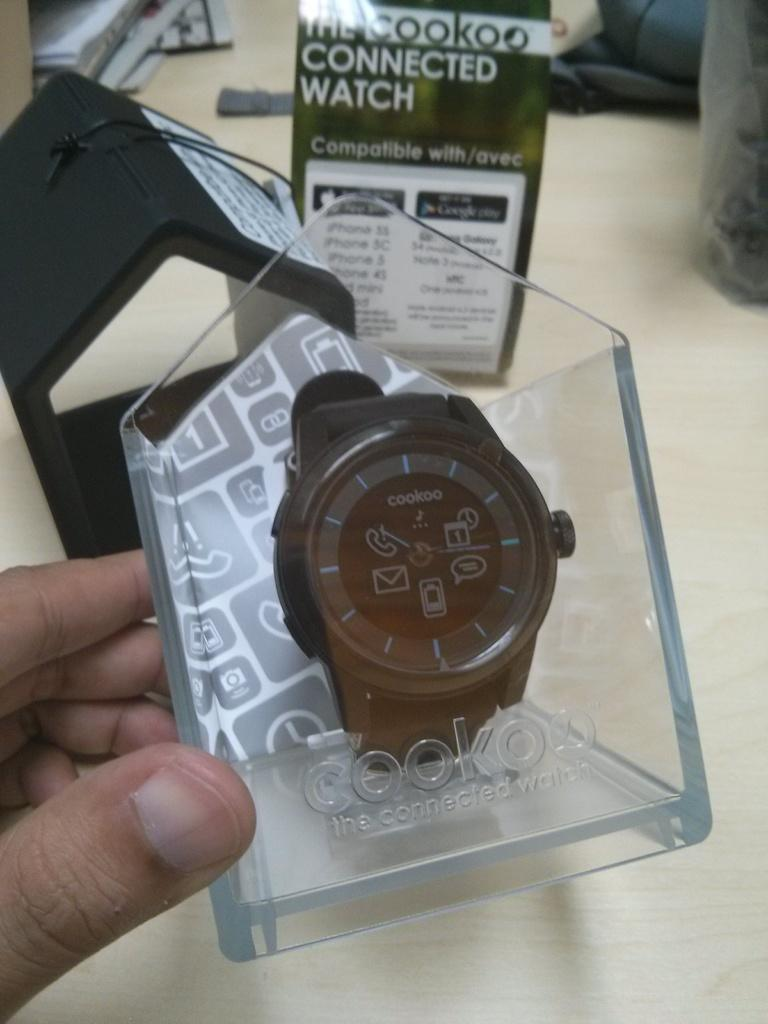<image>
Describe the image concisely. Cookoo watch is displayed in a clear case 